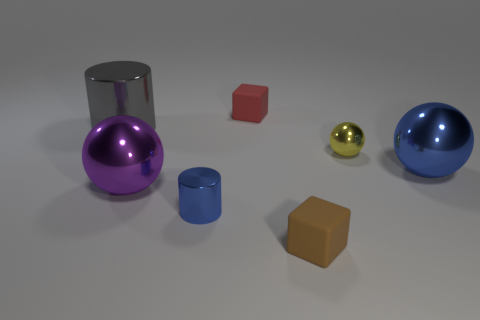Is the small red cube made of the same material as the block in front of the purple metal sphere?
Ensure brevity in your answer.  Yes. What number of other objects are the same shape as the big purple metal object?
Ensure brevity in your answer.  2. Is the color of the tiny metal cylinder the same as the large ball right of the brown matte cube?
Give a very brief answer. Yes. There is a blue object that is on the right side of the tiny rubber object in front of the big purple ball; what shape is it?
Offer a terse response. Sphere. There is a sphere that is the same color as the small cylinder; what is its size?
Your answer should be very brief. Large. There is a blue shiny object that is to the left of the brown rubber thing; is it the same shape as the big gray thing?
Keep it short and to the point. Yes. Is the number of objects on the left side of the large blue sphere greater than the number of large gray metal objects on the left side of the big gray cylinder?
Your response must be concise. Yes. There is a rubber object that is on the right side of the red rubber cube; how many spheres are on the right side of it?
Your answer should be compact. 2. How many other things are there of the same color as the large metal cylinder?
Make the answer very short. 0. What color is the tiny rubber object that is in front of the tiny metal object on the right side of the brown object?
Your answer should be very brief. Brown. 